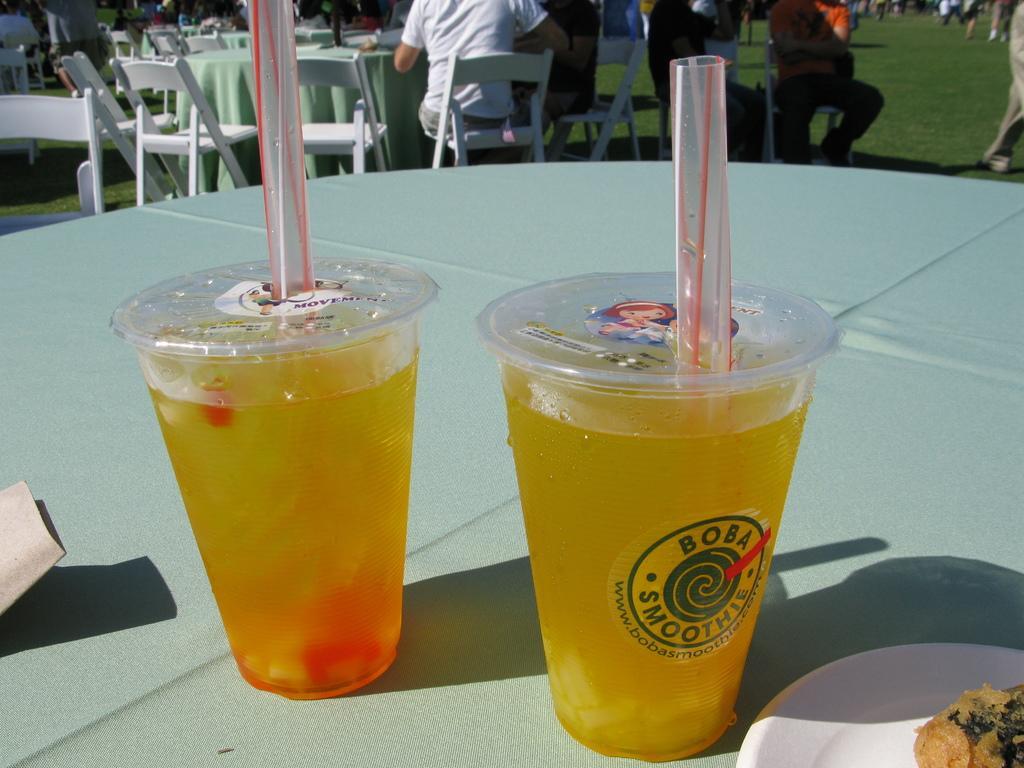How would you summarize this image in a sentence or two? These are the 2 drinks with the straws in it, on the right side there is a plate in white color on the table. 